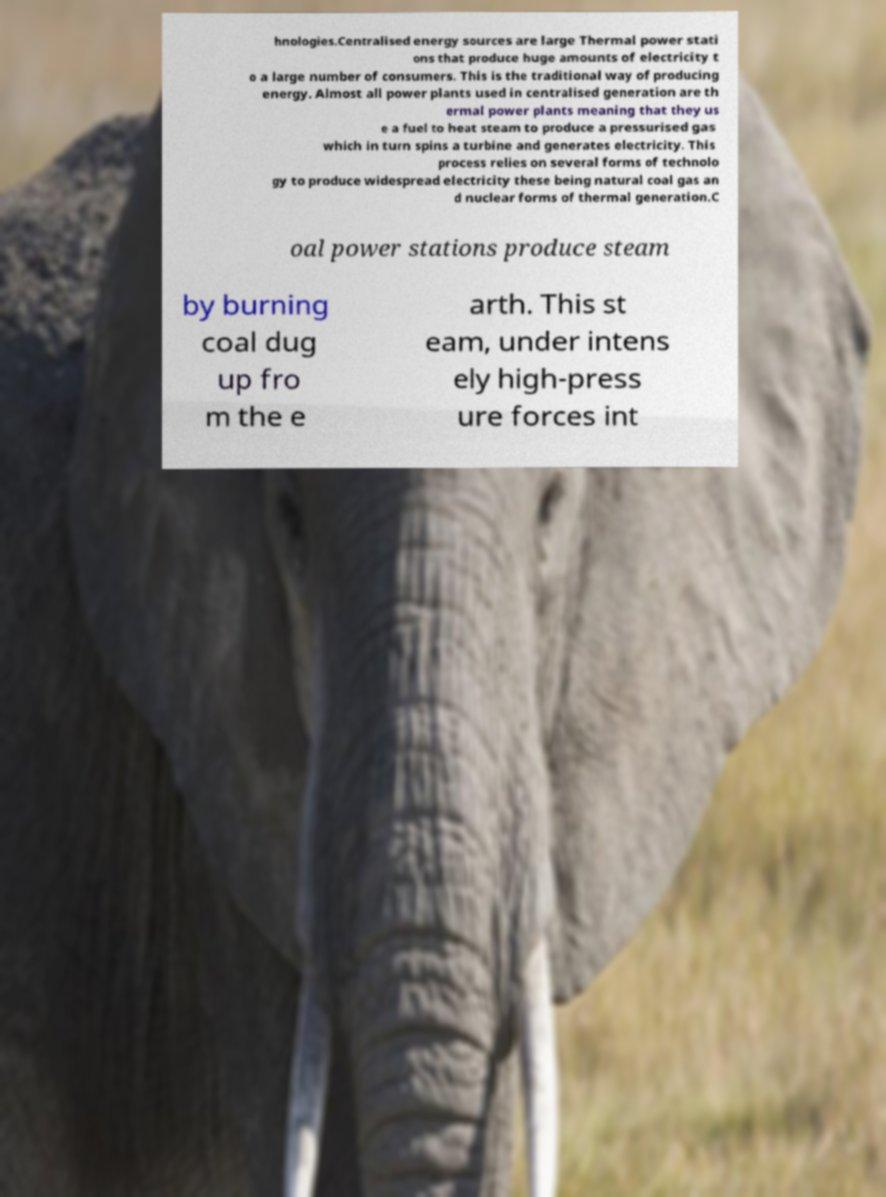Please identify and transcribe the text found in this image. hnologies.Centralised energy sources are large Thermal power stati ons that produce huge amounts of electricity t o a large number of consumers. This is the traditional way of producing energy. Almost all power plants used in centralised generation are th ermal power plants meaning that they us e a fuel to heat steam to produce a pressurised gas which in turn spins a turbine and generates electricity. This process relies on several forms of technolo gy to produce widespread electricity these being natural coal gas an d nuclear forms of thermal generation.C oal power stations produce steam by burning coal dug up fro m the e arth. This st eam, under intens ely high-press ure forces int 